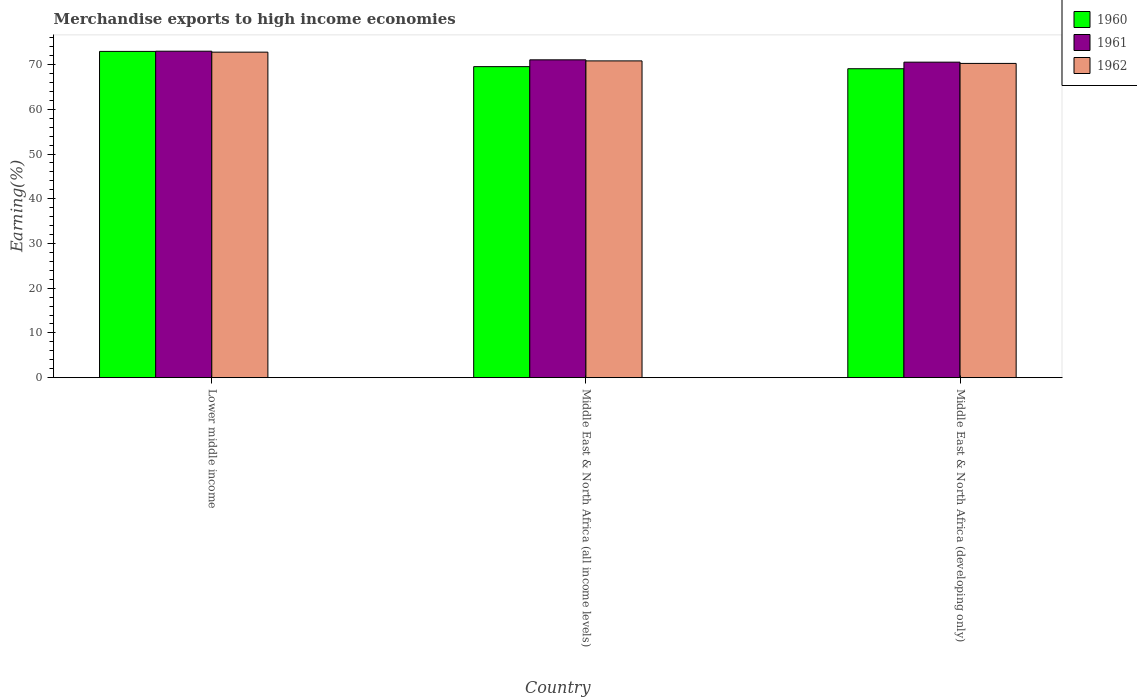How many different coloured bars are there?
Offer a terse response. 3. Are the number of bars per tick equal to the number of legend labels?
Offer a very short reply. Yes. Are the number of bars on each tick of the X-axis equal?
Provide a succinct answer. Yes. How many bars are there on the 1st tick from the left?
Offer a terse response. 3. How many bars are there on the 2nd tick from the right?
Offer a terse response. 3. What is the label of the 2nd group of bars from the left?
Your response must be concise. Middle East & North Africa (all income levels). In how many cases, is the number of bars for a given country not equal to the number of legend labels?
Your answer should be compact. 0. What is the percentage of amount earned from merchandise exports in 1960 in Middle East & North Africa (all income levels)?
Ensure brevity in your answer.  69.53. Across all countries, what is the maximum percentage of amount earned from merchandise exports in 1962?
Ensure brevity in your answer.  72.77. Across all countries, what is the minimum percentage of amount earned from merchandise exports in 1961?
Keep it short and to the point. 70.53. In which country was the percentage of amount earned from merchandise exports in 1962 maximum?
Provide a succinct answer. Lower middle income. In which country was the percentage of amount earned from merchandise exports in 1961 minimum?
Offer a very short reply. Middle East & North Africa (developing only). What is the total percentage of amount earned from merchandise exports in 1962 in the graph?
Your answer should be very brief. 213.84. What is the difference between the percentage of amount earned from merchandise exports in 1961 in Lower middle income and that in Middle East & North Africa (all income levels)?
Your answer should be very brief. 1.93. What is the difference between the percentage of amount earned from merchandise exports in 1962 in Lower middle income and the percentage of amount earned from merchandise exports in 1961 in Middle East & North Africa (all income levels)?
Give a very brief answer. 1.72. What is the average percentage of amount earned from merchandise exports in 1960 per country?
Make the answer very short. 70.51. What is the difference between the percentage of amount earned from merchandise exports of/in 1962 and percentage of amount earned from merchandise exports of/in 1961 in Lower middle income?
Offer a terse response. -0.21. What is the ratio of the percentage of amount earned from merchandise exports in 1960 in Lower middle income to that in Middle East & North Africa (developing only)?
Ensure brevity in your answer.  1.06. Is the percentage of amount earned from merchandise exports in 1962 in Lower middle income less than that in Middle East & North Africa (developing only)?
Provide a short and direct response. No. What is the difference between the highest and the second highest percentage of amount earned from merchandise exports in 1960?
Offer a very short reply. 3.88. What is the difference between the highest and the lowest percentage of amount earned from merchandise exports in 1961?
Offer a very short reply. 2.45. In how many countries, is the percentage of amount earned from merchandise exports in 1961 greater than the average percentage of amount earned from merchandise exports in 1961 taken over all countries?
Your response must be concise. 1. Is the sum of the percentage of amount earned from merchandise exports in 1962 in Lower middle income and Middle East & North Africa (all income levels) greater than the maximum percentage of amount earned from merchandise exports in 1961 across all countries?
Give a very brief answer. Yes. How many bars are there?
Provide a succinct answer. 9. Are all the bars in the graph horizontal?
Make the answer very short. No. How many countries are there in the graph?
Provide a short and direct response. 3. Does the graph contain any zero values?
Offer a terse response. No. Does the graph contain grids?
Offer a very short reply. No. What is the title of the graph?
Your response must be concise. Merchandise exports to high income economies. Does "1962" appear as one of the legend labels in the graph?
Give a very brief answer. Yes. What is the label or title of the X-axis?
Your response must be concise. Country. What is the label or title of the Y-axis?
Give a very brief answer. Earning(%). What is the Earning(%) of 1960 in Lower middle income?
Your answer should be very brief. 72.94. What is the Earning(%) of 1961 in Lower middle income?
Your answer should be very brief. 72.98. What is the Earning(%) in 1962 in Lower middle income?
Make the answer very short. 72.77. What is the Earning(%) in 1960 in Middle East & North Africa (all income levels)?
Provide a succinct answer. 69.53. What is the Earning(%) in 1961 in Middle East & North Africa (all income levels)?
Your response must be concise. 71.05. What is the Earning(%) in 1962 in Middle East & North Africa (all income levels)?
Give a very brief answer. 70.82. What is the Earning(%) in 1960 in Middle East & North Africa (developing only)?
Provide a short and direct response. 69.06. What is the Earning(%) of 1961 in Middle East & North Africa (developing only)?
Keep it short and to the point. 70.53. What is the Earning(%) in 1962 in Middle East & North Africa (developing only)?
Your answer should be compact. 70.25. Across all countries, what is the maximum Earning(%) in 1960?
Your answer should be very brief. 72.94. Across all countries, what is the maximum Earning(%) in 1961?
Ensure brevity in your answer.  72.98. Across all countries, what is the maximum Earning(%) of 1962?
Make the answer very short. 72.77. Across all countries, what is the minimum Earning(%) in 1960?
Keep it short and to the point. 69.06. Across all countries, what is the minimum Earning(%) of 1961?
Your answer should be very brief. 70.53. Across all countries, what is the minimum Earning(%) of 1962?
Ensure brevity in your answer.  70.25. What is the total Earning(%) of 1960 in the graph?
Provide a short and direct response. 211.54. What is the total Earning(%) of 1961 in the graph?
Provide a succinct answer. 214.57. What is the total Earning(%) of 1962 in the graph?
Keep it short and to the point. 213.84. What is the difference between the Earning(%) in 1960 in Lower middle income and that in Middle East & North Africa (all income levels)?
Your response must be concise. 3.41. What is the difference between the Earning(%) of 1961 in Lower middle income and that in Middle East & North Africa (all income levels)?
Your answer should be very brief. 1.93. What is the difference between the Earning(%) in 1962 in Lower middle income and that in Middle East & North Africa (all income levels)?
Give a very brief answer. 1.96. What is the difference between the Earning(%) of 1960 in Lower middle income and that in Middle East & North Africa (developing only)?
Offer a terse response. 3.88. What is the difference between the Earning(%) in 1961 in Lower middle income and that in Middle East & North Africa (developing only)?
Your answer should be compact. 2.45. What is the difference between the Earning(%) in 1962 in Lower middle income and that in Middle East & North Africa (developing only)?
Your answer should be very brief. 2.52. What is the difference between the Earning(%) in 1960 in Middle East & North Africa (all income levels) and that in Middle East & North Africa (developing only)?
Your answer should be compact. 0.47. What is the difference between the Earning(%) in 1961 in Middle East & North Africa (all income levels) and that in Middle East & North Africa (developing only)?
Your answer should be compact. 0.52. What is the difference between the Earning(%) of 1962 in Middle East & North Africa (all income levels) and that in Middle East & North Africa (developing only)?
Your answer should be compact. 0.56. What is the difference between the Earning(%) of 1960 in Lower middle income and the Earning(%) of 1961 in Middle East & North Africa (all income levels)?
Give a very brief answer. 1.89. What is the difference between the Earning(%) in 1960 in Lower middle income and the Earning(%) in 1962 in Middle East & North Africa (all income levels)?
Your answer should be compact. 2.12. What is the difference between the Earning(%) of 1961 in Lower middle income and the Earning(%) of 1962 in Middle East & North Africa (all income levels)?
Offer a very short reply. 2.17. What is the difference between the Earning(%) in 1960 in Lower middle income and the Earning(%) in 1961 in Middle East & North Africa (developing only)?
Give a very brief answer. 2.41. What is the difference between the Earning(%) in 1960 in Lower middle income and the Earning(%) in 1962 in Middle East & North Africa (developing only)?
Your answer should be compact. 2.69. What is the difference between the Earning(%) in 1961 in Lower middle income and the Earning(%) in 1962 in Middle East & North Africa (developing only)?
Give a very brief answer. 2.73. What is the difference between the Earning(%) in 1960 in Middle East & North Africa (all income levels) and the Earning(%) in 1961 in Middle East & North Africa (developing only)?
Provide a short and direct response. -1. What is the difference between the Earning(%) in 1960 in Middle East & North Africa (all income levels) and the Earning(%) in 1962 in Middle East & North Africa (developing only)?
Keep it short and to the point. -0.72. What is the difference between the Earning(%) in 1961 in Middle East & North Africa (all income levels) and the Earning(%) in 1962 in Middle East & North Africa (developing only)?
Offer a terse response. 0.8. What is the average Earning(%) in 1960 per country?
Make the answer very short. 70.51. What is the average Earning(%) of 1961 per country?
Ensure brevity in your answer.  71.52. What is the average Earning(%) in 1962 per country?
Provide a short and direct response. 71.28. What is the difference between the Earning(%) of 1960 and Earning(%) of 1961 in Lower middle income?
Ensure brevity in your answer.  -0.04. What is the difference between the Earning(%) of 1960 and Earning(%) of 1962 in Lower middle income?
Make the answer very short. 0.17. What is the difference between the Earning(%) in 1961 and Earning(%) in 1962 in Lower middle income?
Your response must be concise. 0.21. What is the difference between the Earning(%) of 1960 and Earning(%) of 1961 in Middle East & North Africa (all income levels)?
Your answer should be very brief. -1.52. What is the difference between the Earning(%) of 1960 and Earning(%) of 1962 in Middle East & North Africa (all income levels)?
Keep it short and to the point. -1.28. What is the difference between the Earning(%) in 1961 and Earning(%) in 1962 in Middle East & North Africa (all income levels)?
Ensure brevity in your answer.  0.24. What is the difference between the Earning(%) in 1960 and Earning(%) in 1961 in Middle East & North Africa (developing only)?
Your response must be concise. -1.47. What is the difference between the Earning(%) of 1960 and Earning(%) of 1962 in Middle East & North Africa (developing only)?
Keep it short and to the point. -1.19. What is the difference between the Earning(%) in 1961 and Earning(%) in 1962 in Middle East & North Africa (developing only)?
Your answer should be very brief. 0.28. What is the ratio of the Earning(%) of 1960 in Lower middle income to that in Middle East & North Africa (all income levels)?
Your answer should be very brief. 1.05. What is the ratio of the Earning(%) of 1961 in Lower middle income to that in Middle East & North Africa (all income levels)?
Make the answer very short. 1.03. What is the ratio of the Earning(%) of 1962 in Lower middle income to that in Middle East & North Africa (all income levels)?
Provide a short and direct response. 1.03. What is the ratio of the Earning(%) of 1960 in Lower middle income to that in Middle East & North Africa (developing only)?
Provide a succinct answer. 1.06. What is the ratio of the Earning(%) of 1961 in Lower middle income to that in Middle East & North Africa (developing only)?
Your response must be concise. 1.03. What is the ratio of the Earning(%) in 1962 in Lower middle income to that in Middle East & North Africa (developing only)?
Offer a very short reply. 1.04. What is the ratio of the Earning(%) of 1960 in Middle East & North Africa (all income levels) to that in Middle East & North Africa (developing only)?
Offer a very short reply. 1.01. What is the ratio of the Earning(%) of 1961 in Middle East & North Africa (all income levels) to that in Middle East & North Africa (developing only)?
Your response must be concise. 1.01. What is the ratio of the Earning(%) of 1962 in Middle East & North Africa (all income levels) to that in Middle East & North Africa (developing only)?
Your response must be concise. 1.01. What is the difference between the highest and the second highest Earning(%) in 1960?
Your answer should be compact. 3.41. What is the difference between the highest and the second highest Earning(%) in 1961?
Offer a terse response. 1.93. What is the difference between the highest and the second highest Earning(%) of 1962?
Offer a very short reply. 1.96. What is the difference between the highest and the lowest Earning(%) of 1960?
Provide a short and direct response. 3.88. What is the difference between the highest and the lowest Earning(%) of 1961?
Provide a short and direct response. 2.45. What is the difference between the highest and the lowest Earning(%) of 1962?
Give a very brief answer. 2.52. 